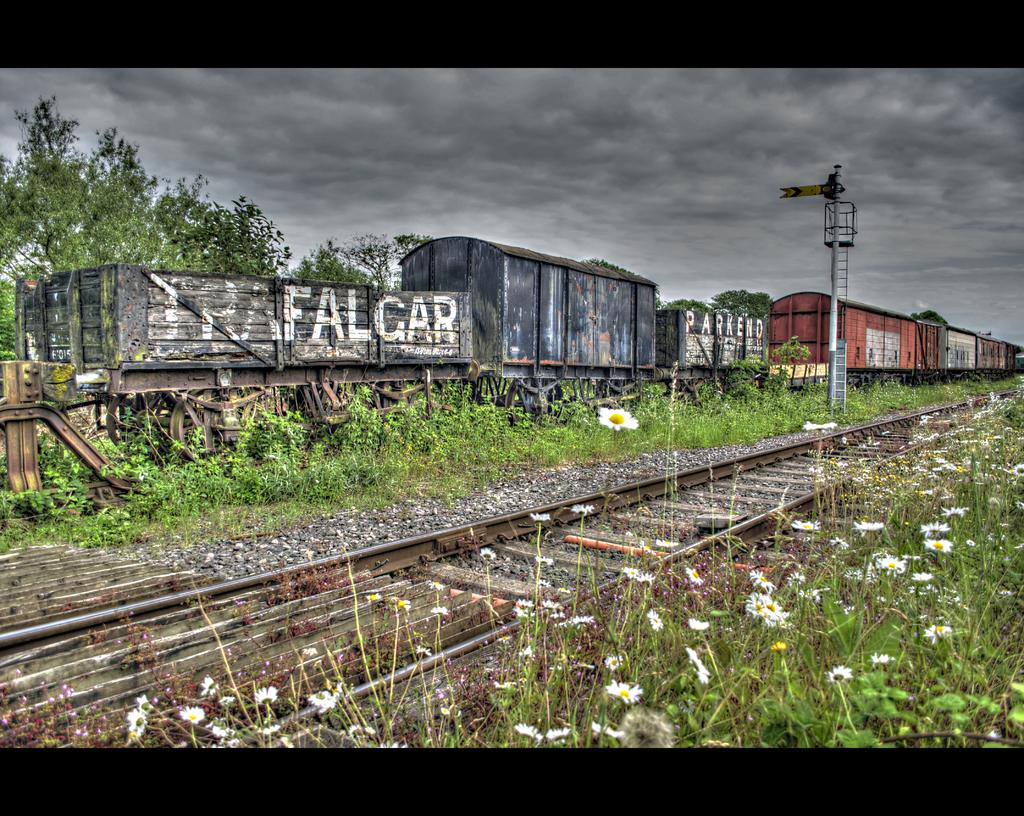What is the main feature of the image? The main feature of the image is an empty track. What structure can be seen near the track? There is an iron tower in the image. What type of plants are present in the image? There are flower plants and trees in the image. What type of train is visible in the image? There is a goods train in the image. What time does the watch show in the image? There is no watch present in the image. How does the stomach of the flower plant feel in the image? Flower plants do not have stomachs, as they are not living beings with digestive systems. 